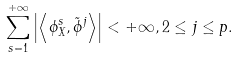<formula> <loc_0><loc_0><loc_500><loc_500>\sum ^ { + \infty } _ { s = 1 } \left | \left \langle \phi _ { X } ^ { s } , \tilde { \phi } ^ { j } \right \rangle \right | < + \infty , 2 \leq j \leq p .</formula> 